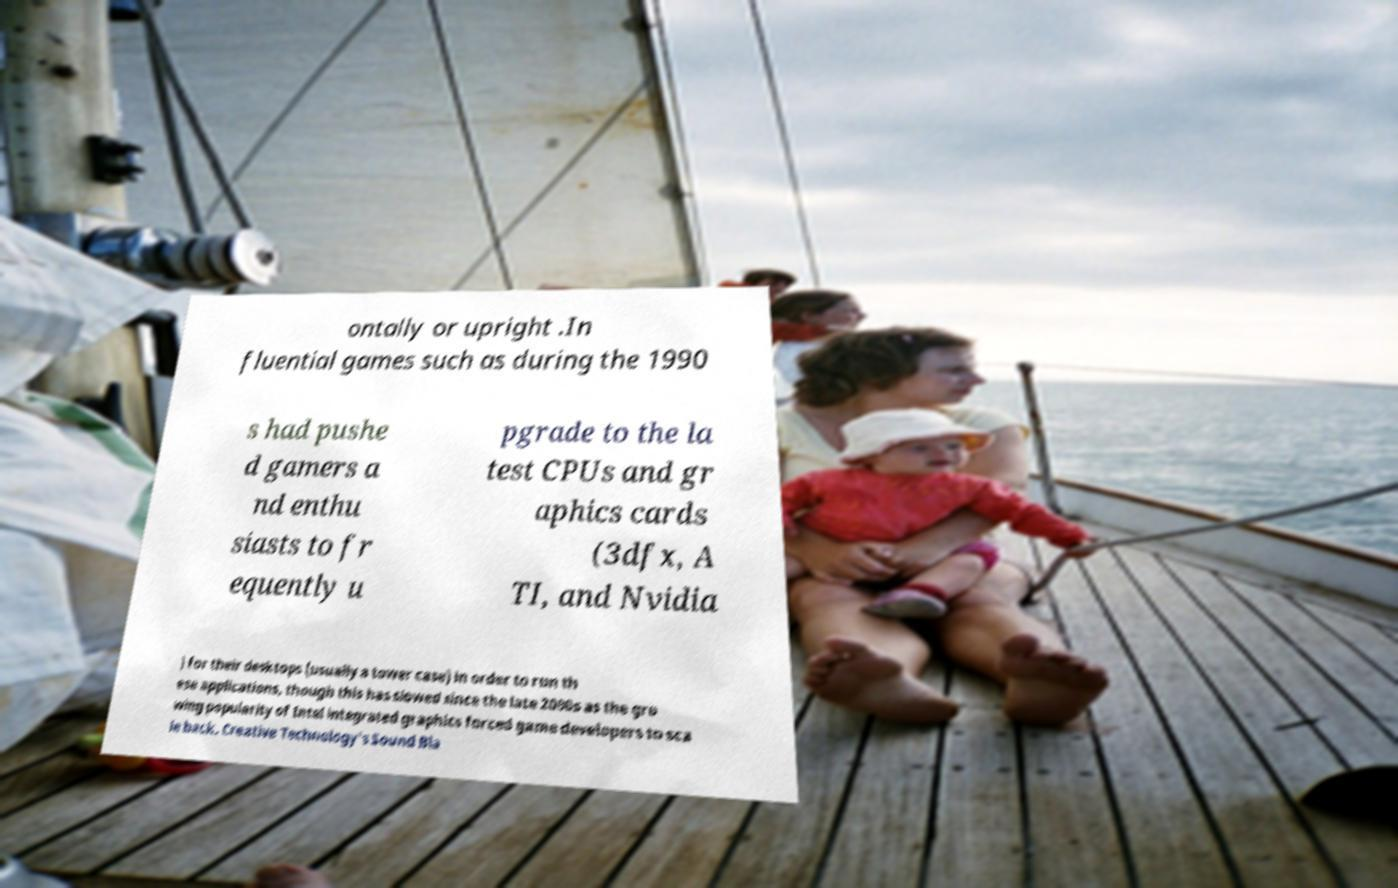Can you accurately transcribe the text from the provided image for me? ontally or upright .In fluential games such as during the 1990 s had pushe d gamers a nd enthu siasts to fr equently u pgrade to the la test CPUs and gr aphics cards (3dfx, A TI, and Nvidia ) for their desktops (usually a tower case) in order to run th ese applications, though this has slowed since the late 2000s as the gro wing popularity of Intel integrated graphics forced game developers to sca le back. Creative Technology's Sound Bla 